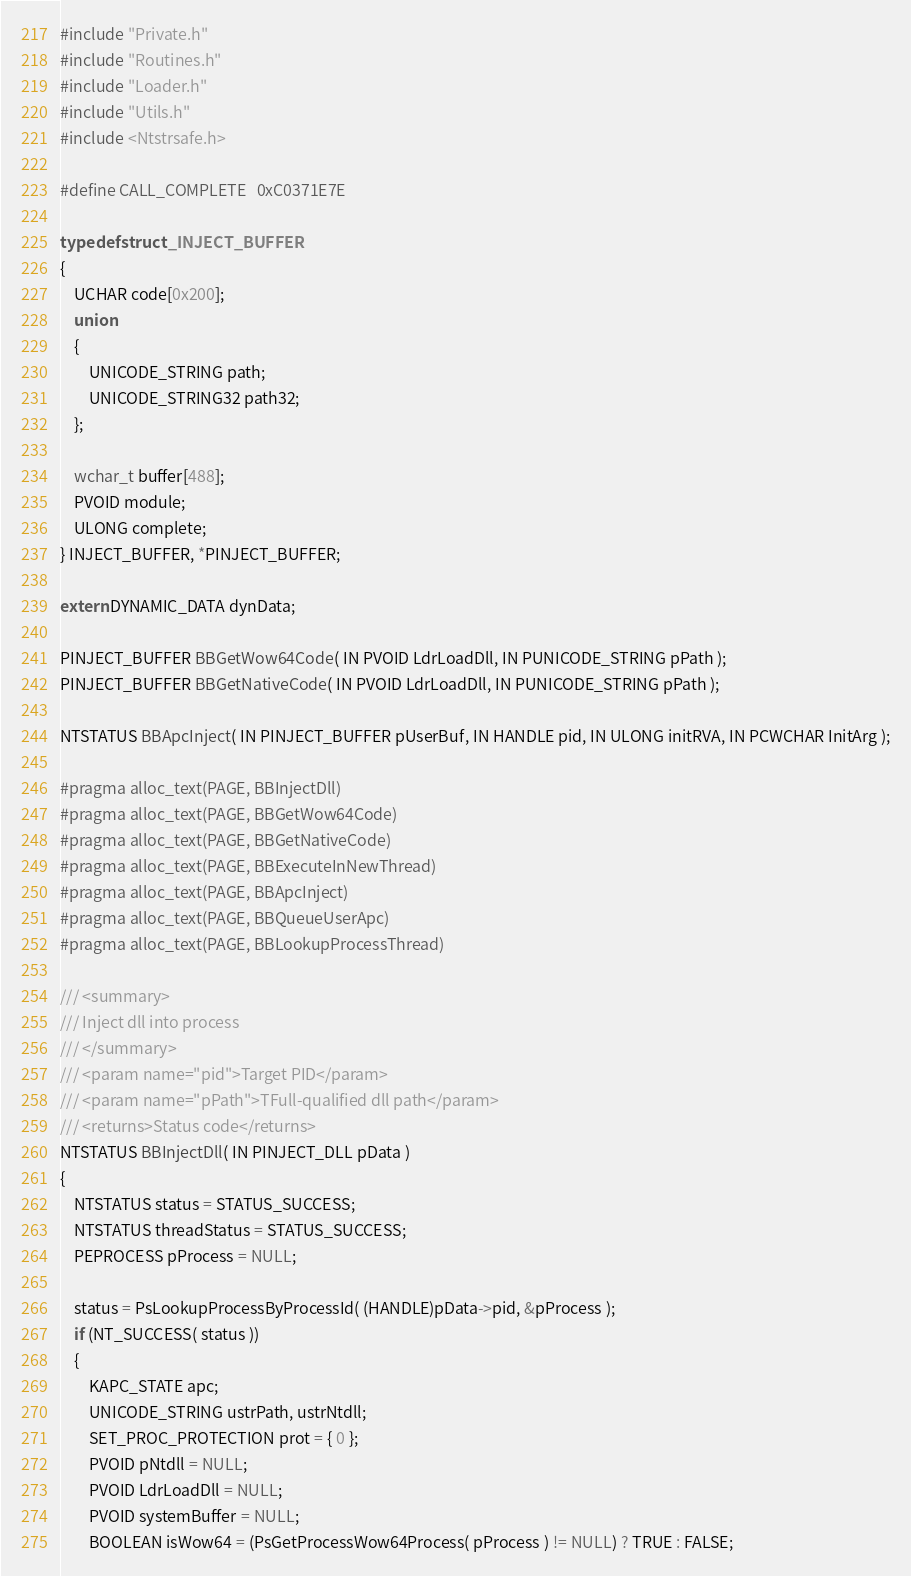<code> <loc_0><loc_0><loc_500><loc_500><_C_>#include "Private.h"
#include "Routines.h"
#include "Loader.h"
#include "Utils.h"
#include <Ntstrsafe.h>

#define CALL_COMPLETE   0xC0371E7E

typedef struct _INJECT_BUFFER
{
    UCHAR code[0x200];
    union
    {
        UNICODE_STRING path;
        UNICODE_STRING32 path32;
    };

    wchar_t buffer[488];
    PVOID module;
    ULONG complete;
} INJECT_BUFFER, *PINJECT_BUFFER;

extern DYNAMIC_DATA dynData;

PINJECT_BUFFER BBGetWow64Code( IN PVOID LdrLoadDll, IN PUNICODE_STRING pPath );
PINJECT_BUFFER BBGetNativeCode( IN PVOID LdrLoadDll, IN PUNICODE_STRING pPath );

NTSTATUS BBApcInject( IN PINJECT_BUFFER pUserBuf, IN HANDLE pid, IN ULONG initRVA, IN PCWCHAR InitArg );

#pragma alloc_text(PAGE, BBInjectDll)
#pragma alloc_text(PAGE, BBGetWow64Code)
#pragma alloc_text(PAGE, BBGetNativeCode)
#pragma alloc_text(PAGE, BBExecuteInNewThread)
#pragma alloc_text(PAGE, BBApcInject)
#pragma alloc_text(PAGE, BBQueueUserApc)
#pragma alloc_text(PAGE, BBLookupProcessThread)

/// <summary>
/// Inject dll into process
/// </summary>
/// <param name="pid">Target PID</param>
/// <param name="pPath">TFull-qualified dll path</param>
/// <returns>Status code</returns>
NTSTATUS BBInjectDll( IN PINJECT_DLL pData )
{
    NTSTATUS status = STATUS_SUCCESS;
    NTSTATUS threadStatus = STATUS_SUCCESS;
    PEPROCESS pProcess = NULL;

    status = PsLookupProcessByProcessId( (HANDLE)pData->pid, &pProcess );
    if (NT_SUCCESS( status ))
    {
        KAPC_STATE apc;
        UNICODE_STRING ustrPath, ustrNtdll;
        SET_PROC_PROTECTION prot = { 0 };
        PVOID pNtdll = NULL;
        PVOID LdrLoadDll = NULL;
        PVOID systemBuffer = NULL;
        BOOLEAN isWow64 = (PsGetProcessWow64Process( pProcess ) != NULL) ? TRUE : FALSE;
</code> 